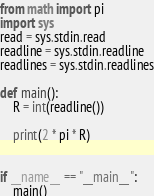<code> <loc_0><loc_0><loc_500><loc_500><_Python_>from math import pi
import sys
read = sys.stdin.read
readline = sys.stdin.readline
readlines = sys.stdin.readlines

def main():
    R = int(readline())

    print(2 * pi * R)


if __name__ == "__main__":
    main()
</code> 